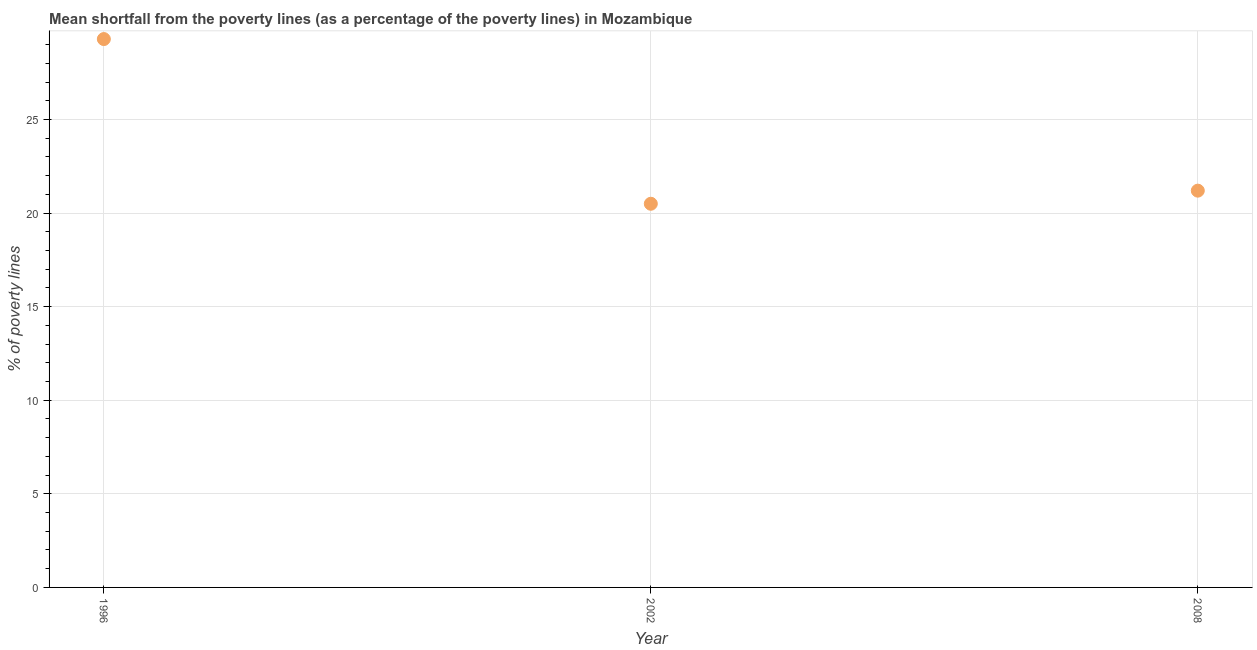What is the poverty gap at national poverty lines in 2008?
Your answer should be very brief. 21.2. Across all years, what is the maximum poverty gap at national poverty lines?
Your answer should be compact. 29.3. Across all years, what is the minimum poverty gap at national poverty lines?
Your response must be concise. 20.5. What is the sum of the poverty gap at national poverty lines?
Offer a very short reply. 71. What is the difference between the poverty gap at national poverty lines in 1996 and 2002?
Your response must be concise. 8.8. What is the average poverty gap at national poverty lines per year?
Your answer should be compact. 23.67. What is the median poverty gap at national poverty lines?
Your answer should be compact. 21.2. Do a majority of the years between 1996 and 2008 (inclusive) have poverty gap at national poverty lines greater than 17 %?
Make the answer very short. Yes. What is the ratio of the poverty gap at national poverty lines in 1996 to that in 2008?
Your response must be concise. 1.38. Is the poverty gap at national poverty lines in 1996 less than that in 2008?
Offer a very short reply. No. Is the difference between the poverty gap at national poverty lines in 2002 and 2008 greater than the difference between any two years?
Your answer should be compact. No. What is the difference between the highest and the second highest poverty gap at national poverty lines?
Your response must be concise. 8.1. Is the sum of the poverty gap at national poverty lines in 2002 and 2008 greater than the maximum poverty gap at national poverty lines across all years?
Your answer should be compact. Yes. What is the difference between the highest and the lowest poverty gap at national poverty lines?
Make the answer very short. 8.8. In how many years, is the poverty gap at national poverty lines greater than the average poverty gap at national poverty lines taken over all years?
Make the answer very short. 1. Does the poverty gap at national poverty lines monotonically increase over the years?
Provide a succinct answer. No. How many years are there in the graph?
Give a very brief answer. 3. Does the graph contain any zero values?
Provide a short and direct response. No. What is the title of the graph?
Ensure brevity in your answer.  Mean shortfall from the poverty lines (as a percentage of the poverty lines) in Mozambique. What is the label or title of the Y-axis?
Make the answer very short. % of poverty lines. What is the % of poverty lines in 1996?
Your answer should be very brief. 29.3. What is the % of poverty lines in 2002?
Make the answer very short. 20.5. What is the % of poverty lines in 2008?
Make the answer very short. 21.2. What is the difference between the % of poverty lines in 1996 and 2008?
Provide a short and direct response. 8.1. What is the difference between the % of poverty lines in 2002 and 2008?
Offer a very short reply. -0.7. What is the ratio of the % of poverty lines in 1996 to that in 2002?
Give a very brief answer. 1.43. What is the ratio of the % of poverty lines in 1996 to that in 2008?
Offer a very short reply. 1.38. 